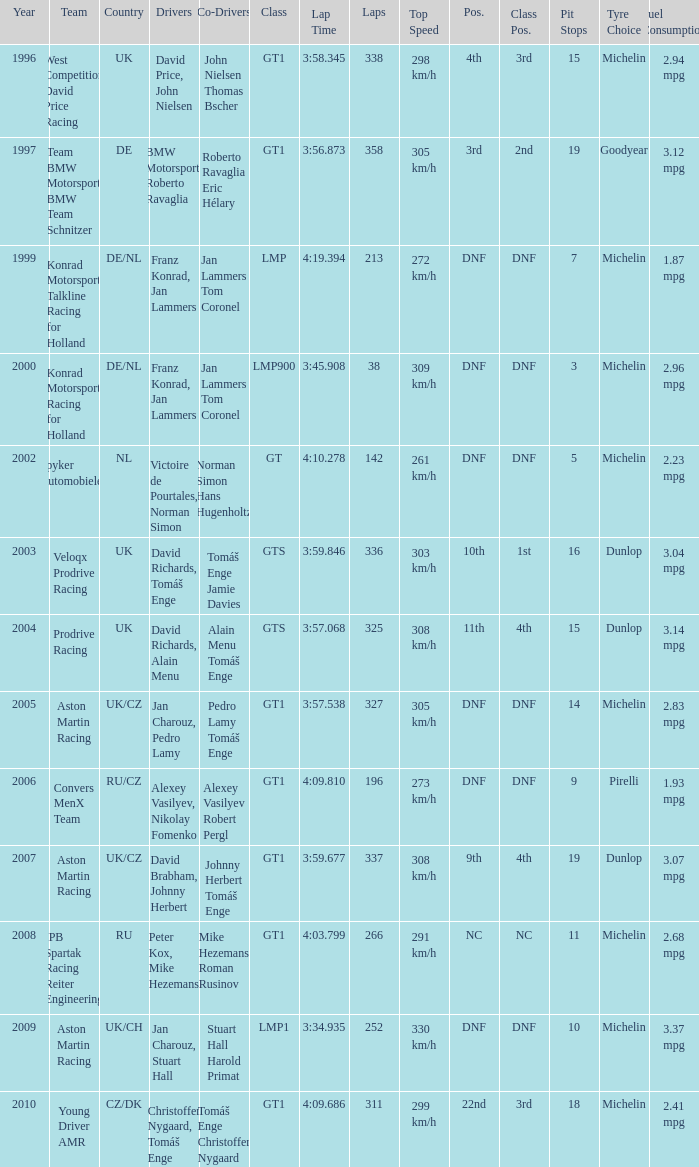Which position finished 3rd in class and completed less than 338 laps? 22nd. 